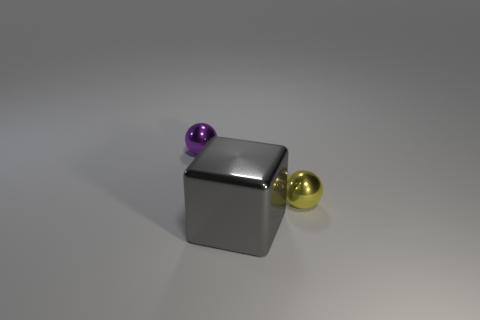Add 1 yellow rubber blocks. How many objects exist? 4 Subtract all cubes. How many objects are left? 2 Subtract 0 green spheres. How many objects are left? 3 Subtract all gray things. Subtract all big gray metallic things. How many objects are left? 1 Add 1 small yellow metal balls. How many small yellow metal balls are left? 2 Add 3 big brown blocks. How many big brown blocks exist? 3 